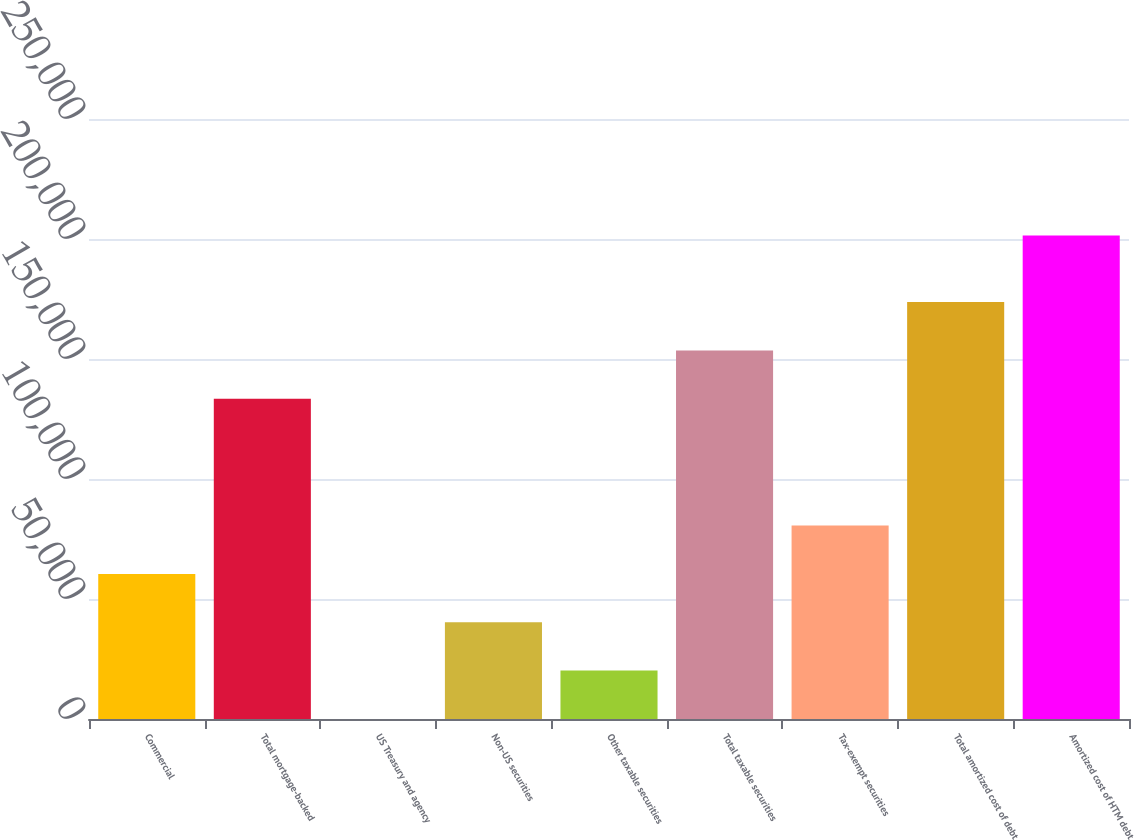Convert chart. <chart><loc_0><loc_0><loc_500><loc_500><bar_chart><fcel>Commercial<fcel>Total mortgage-backed<fcel>US Treasury and agency<fcel>Non-US securities<fcel>Other taxable securities<fcel>Total taxable securities<fcel>Tax-exempt securities<fcel>Total amortized cost of debt<fcel>Amortized cost of HTM debt<nl><fcel>60465.3<fcel>133444<fcel>21<fcel>40317.2<fcel>20169.1<fcel>153592<fcel>80613.4<fcel>173740<fcel>201502<nl></chart> 